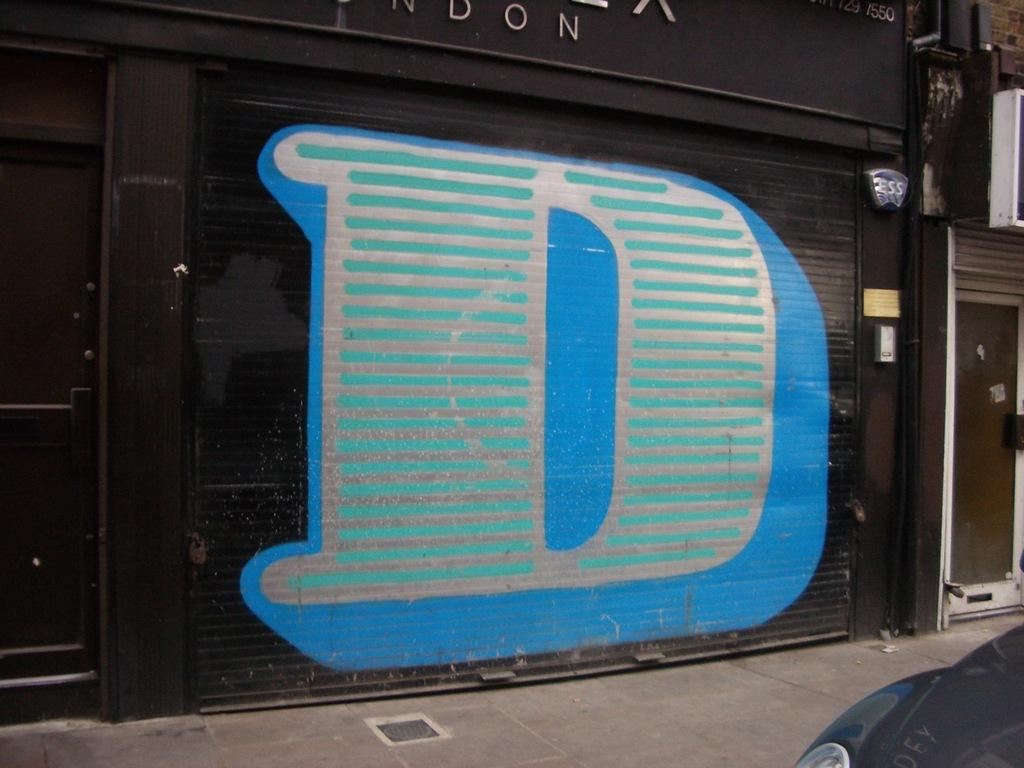What type of structure is in the image? There is a building in the image. What feature can be seen on the building? The building has a black shutter. What is written on the shutter? The letter "d" is painted on the shutter. What vehicle is present in the image? There is a black car in the image. On which side of the image is the car located? The car is located on the right side of the image. Who is the expert in humor and art that can be seen in the image? There is no expert in humor and art present in the image; the image only features a building with a black shutter and a black car on the right side. 